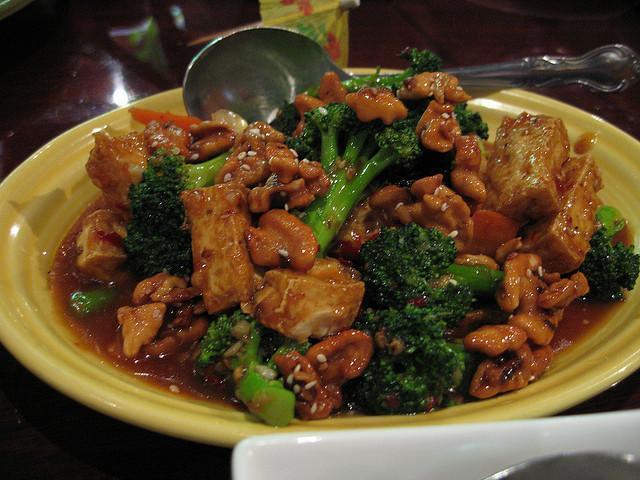What is the food covered in to make it orange?
Choose the correct response and explain in the format: 'Answer: answer
Rationale: rationale.'
Options: Spit, gasoline, sauce, soda. Answer: sauce.
Rationale: The food has sauce. 